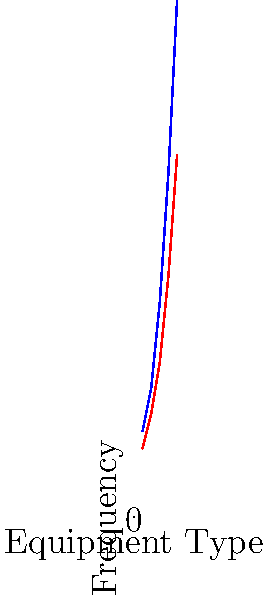Based on the surveillance data presented in the graph, which equipment type shows the most significant difference in frequency between suspicious and non-suspicious classifications, potentially indicating a higher risk for bioterrorism applications? To determine which equipment type shows the most significant difference between suspicious and non-suspicious classifications, we need to analyze the graph step-by-step:

1. The x-axis represents different equipment types (1 through 5).
2. The y-axis shows the frequency of occurrence.
3. Blue line represents suspicious equipment, while the red line represents non-suspicious equipment.
4. We need to calculate the difference between suspicious and non-suspicious frequencies for each equipment type:

   Type 1: $10 - 8 = 2$
   Type 2: $15 - 12 = 3$
   Type 3: $25 - 18 = 7$
   Type 4: $40 - 28 = 12$
   Type 5: $60 - 42 = 18$

5. The largest difference is for Type 5 equipment, with a difference of 18.

This significant difference suggests that Type 5 equipment is more frequently classified as suspicious compared to non-suspicious, indicating a higher potential risk for bioterrorism applications.
Answer: Type 5 